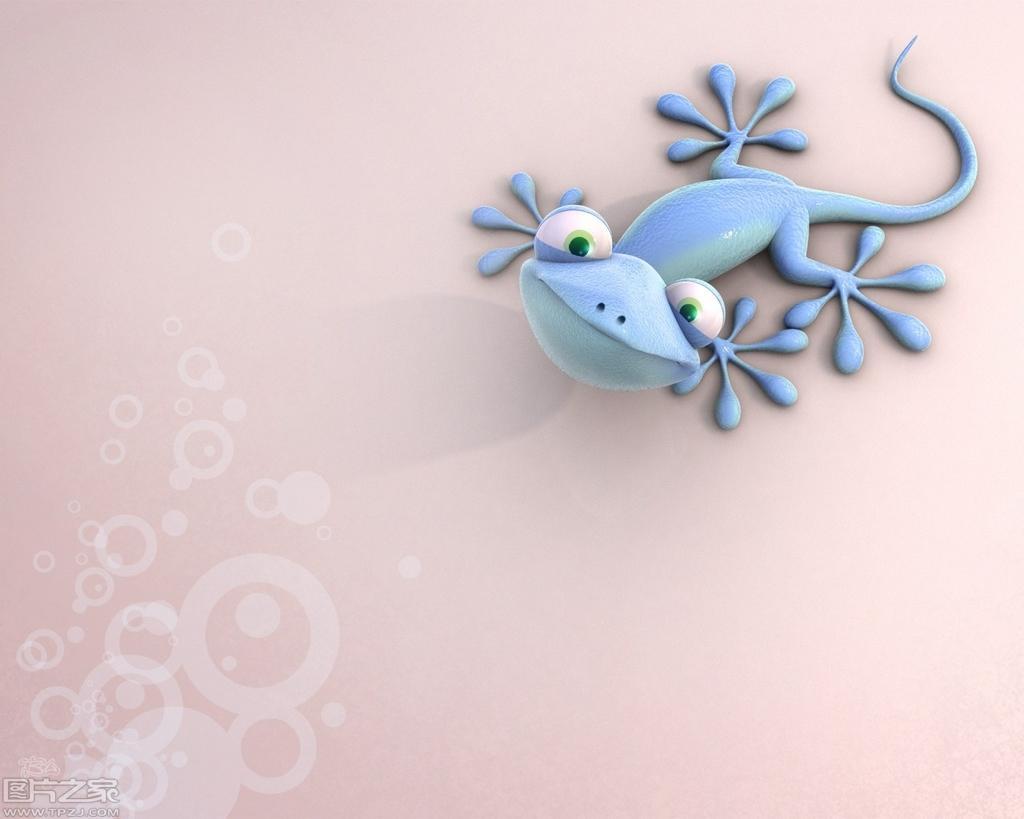Can you describe this image briefly? In this image we can see a lizard on the surface. This is an animated image. There is a watermark on the image. 